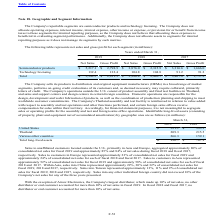From Microchip Technology's financial document, Which years does the table provide information for Identifiable long-lived assets (consisting of property, plant and equipment net of accumulated amortization) by geographic area? The document shows two values: 2019 and 2018. From the document: "2019 2018 2017 2019 2018 2017..." Also, What was the amount of assets in the United States in 2018? According to the financial document, 393.3 (in millions). The relevant text states: "United States $ 521.1 $ 393.3..." Also, What was the amount of assets in Various other countries in 2019? According to the financial document, 266.3 (in millions). The relevant text states: "Various other countries 266.3 159.1..." Also, can you calculate: What was the change in the amount of assets in Thailand between 2018 and 2019? Based on the calculation: 209.3-215.5, the result is -6.2 (in millions). This is based on the information: "Thailand 209.3 215.5 Thailand 209.3 215.5..." The key data points involved are: 209.3, 215.5. Additionally, Which years did total long-lived assets exceed $800 million? According to the financial document, 2019. The relevant text states: "2019 2018 2017..." Also, can you calculate: What was the percentage change in total long-lived assets between 2018 and 2019? To answer this question, I need to perform calculations using the financial data. The calculation is: (996.7-767.9)/767.9, which equals 29.8 (percentage). This is based on the information: "Total long-lived assets $ 996.7 $ 767.9 Total long-lived assets $ 996.7 $ 767.9..." The key data points involved are: 767.9, 996.7. 